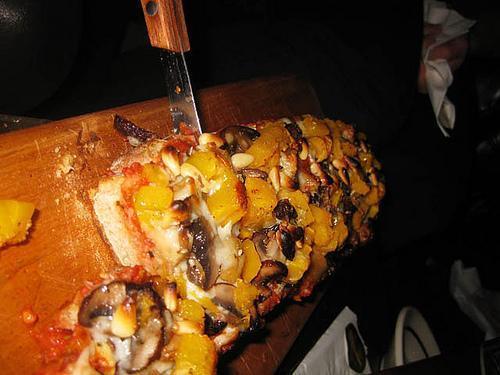How many knives are there?
Give a very brief answer. 1. How many back fridges are in the store?
Give a very brief answer. 0. 